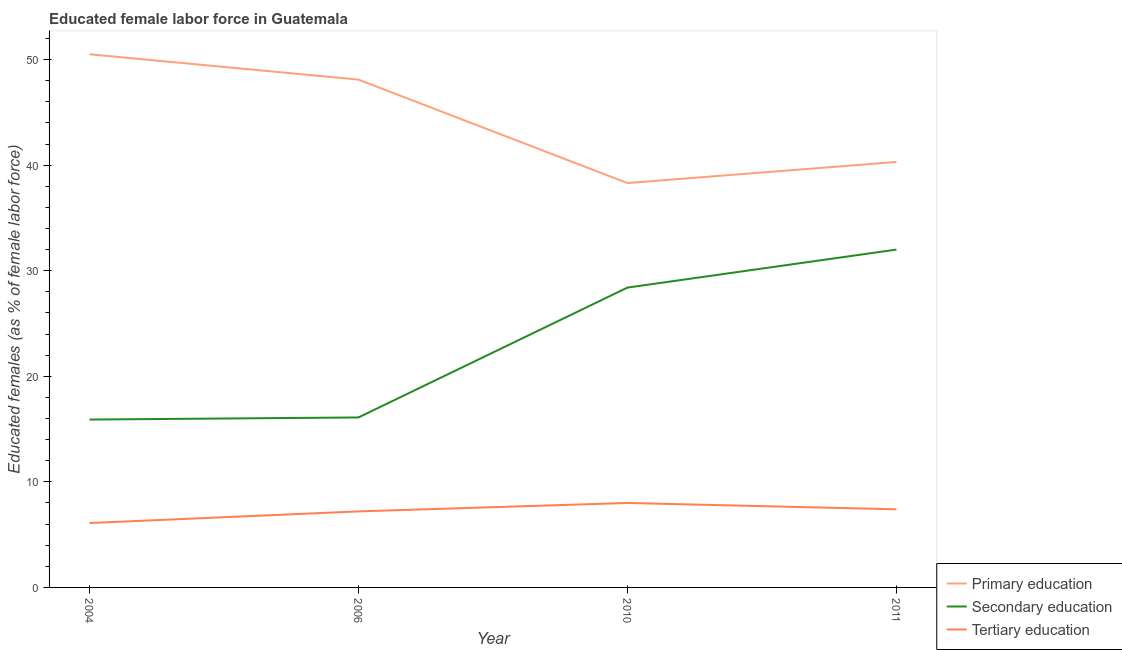How many different coloured lines are there?
Your answer should be very brief. 3. What is the percentage of female labor force who received primary education in 2006?
Offer a very short reply. 48.1. Across all years, what is the maximum percentage of female labor force who received primary education?
Your response must be concise. 50.5. Across all years, what is the minimum percentage of female labor force who received primary education?
Provide a short and direct response. 38.3. What is the total percentage of female labor force who received tertiary education in the graph?
Give a very brief answer. 28.7. What is the difference between the percentage of female labor force who received primary education in 2006 and that in 2011?
Your answer should be very brief. 7.8. What is the difference between the percentage of female labor force who received primary education in 2010 and the percentage of female labor force who received tertiary education in 2011?
Provide a short and direct response. 30.9. What is the average percentage of female labor force who received secondary education per year?
Your answer should be very brief. 23.1. In the year 2011, what is the difference between the percentage of female labor force who received tertiary education and percentage of female labor force who received secondary education?
Provide a short and direct response. -24.6. What is the ratio of the percentage of female labor force who received secondary education in 2004 to that in 2011?
Keep it short and to the point. 0.5. Is the difference between the percentage of female labor force who received primary education in 2004 and 2011 greater than the difference between the percentage of female labor force who received tertiary education in 2004 and 2011?
Your answer should be compact. Yes. What is the difference between the highest and the second highest percentage of female labor force who received secondary education?
Keep it short and to the point. 3.6. What is the difference between the highest and the lowest percentage of female labor force who received primary education?
Give a very brief answer. 12.2. In how many years, is the percentage of female labor force who received secondary education greater than the average percentage of female labor force who received secondary education taken over all years?
Your answer should be compact. 2. Is the percentage of female labor force who received tertiary education strictly less than the percentage of female labor force who received primary education over the years?
Ensure brevity in your answer.  Yes. How many lines are there?
Make the answer very short. 3. How many years are there in the graph?
Offer a terse response. 4. Does the graph contain grids?
Offer a very short reply. No. How many legend labels are there?
Provide a short and direct response. 3. How are the legend labels stacked?
Offer a terse response. Vertical. What is the title of the graph?
Your answer should be compact. Educated female labor force in Guatemala. What is the label or title of the Y-axis?
Keep it short and to the point. Educated females (as % of female labor force). What is the Educated females (as % of female labor force) of Primary education in 2004?
Ensure brevity in your answer.  50.5. What is the Educated females (as % of female labor force) in Secondary education in 2004?
Your response must be concise. 15.9. What is the Educated females (as % of female labor force) of Tertiary education in 2004?
Provide a succinct answer. 6.1. What is the Educated females (as % of female labor force) of Primary education in 2006?
Ensure brevity in your answer.  48.1. What is the Educated females (as % of female labor force) of Secondary education in 2006?
Give a very brief answer. 16.1. What is the Educated females (as % of female labor force) in Tertiary education in 2006?
Your answer should be compact. 7.2. What is the Educated females (as % of female labor force) in Primary education in 2010?
Keep it short and to the point. 38.3. What is the Educated females (as % of female labor force) in Secondary education in 2010?
Your answer should be very brief. 28.4. What is the Educated females (as % of female labor force) in Tertiary education in 2010?
Provide a succinct answer. 8. What is the Educated females (as % of female labor force) of Primary education in 2011?
Offer a very short reply. 40.3. What is the Educated females (as % of female labor force) in Tertiary education in 2011?
Offer a terse response. 7.4. Across all years, what is the maximum Educated females (as % of female labor force) in Primary education?
Make the answer very short. 50.5. Across all years, what is the maximum Educated females (as % of female labor force) in Secondary education?
Provide a succinct answer. 32. Across all years, what is the minimum Educated females (as % of female labor force) in Primary education?
Your response must be concise. 38.3. Across all years, what is the minimum Educated females (as % of female labor force) of Secondary education?
Give a very brief answer. 15.9. Across all years, what is the minimum Educated females (as % of female labor force) in Tertiary education?
Your answer should be compact. 6.1. What is the total Educated females (as % of female labor force) of Primary education in the graph?
Offer a very short reply. 177.2. What is the total Educated females (as % of female labor force) of Secondary education in the graph?
Your response must be concise. 92.4. What is the total Educated females (as % of female labor force) in Tertiary education in the graph?
Give a very brief answer. 28.7. What is the difference between the Educated females (as % of female labor force) in Tertiary education in 2004 and that in 2006?
Provide a short and direct response. -1.1. What is the difference between the Educated females (as % of female labor force) in Primary education in 2004 and that in 2010?
Provide a short and direct response. 12.2. What is the difference between the Educated females (as % of female labor force) of Secondary education in 2004 and that in 2010?
Make the answer very short. -12.5. What is the difference between the Educated females (as % of female labor force) in Secondary education in 2004 and that in 2011?
Offer a terse response. -16.1. What is the difference between the Educated females (as % of female labor force) of Tertiary education in 2004 and that in 2011?
Your answer should be very brief. -1.3. What is the difference between the Educated females (as % of female labor force) of Secondary education in 2006 and that in 2010?
Ensure brevity in your answer.  -12.3. What is the difference between the Educated females (as % of female labor force) in Secondary education in 2006 and that in 2011?
Keep it short and to the point. -15.9. What is the difference between the Educated females (as % of female labor force) in Primary education in 2010 and that in 2011?
Your response must be concise. -2. What is the difference between the Educated females (as % of female labor force) of Secondary education in 2010 and that in 2011?
Your answer should be compact. -3.6. What is the difference between the Educated females (as % of female labor force) of Primary education in 2004 and the Educated females (as % of female labor force) of Secondary education in 2006?
Give a very brief answer. 34.4. What is the difference between the Educated females (as % of female labor force) of Primary education in 2004 and the Educated females (as % of female labor force) of Tertiary education in 2006?
Your answer should be compact. 43.3. What is the difference between the Educated females (as % of female labor force) in Primary education in 2004 and the Educated females (as % of female labor force) in Secondary education in 2010?
Ensure brevity in your answer.  22.1. What is the difference between the Educated females (as % of female labor force) of Primary education in 2004 and the Educated females (as % of female labor force) of Tertiary education in 2010?
Keep it short and to the point. 42.5. What is the difference between the Educated females (as % of female labor force) of Primary education in 2004 and the Educated females (as % of female labor force) of Secondary education in 2011?
Offer a terse response. 18.5. What is the difference between the Educated females (as % of female labor force) of Primary education in 2004 and the Educated females (as % of female labor force) of Tertiary education in 2011?
Offer a very short reply. 43.1. What is the difference between the Educated females (as % of female labor force) of Secondary education in 2004 and the Educated females (as % of female labor force) of Tertiary education in 2011?
Your answer should be compact. 8.5. What is the difference between the Educated females (as % of female labor force) in Primary education in 2006 and the Educated females (as % of female labor force) in Tertiary education in 2010?
Offer a very short reply. 40.1. What is the difference between the Educated females (as % of female labor force) in Secondary education in 2006 and the Educated females (as % of female labor force) in Tertiary education in 2010?
Give a very brief answer. 8.1. What is the difference between the Educated females (as % of female labor force) of Primary education in 2006 and the Educated females (as % of female labor force) of Secondary education in 2011?
Provide a succinct answer. 16.1. What is the difference between the Educated females (as % of female labor force) of Primary education in 2006 and the Educated females (as % of female labor force) of Tertiary education in 2011?
Your answer should be very brief. 40.7. What is the difference between the Educated females (as % of female labor force) of Primary education in 2010 and the Educated females (as % of female labor force) of Tertiary education in 2011?
Your answer should be very brief. 30.9. What is the difference between the Educated females (as % of female labor force) in Secondary education in 2010 and the Educated females (as % of female labor force) in Tertiary education in 2011?
Your answer should be compact. 21. What is the average Educated females (as % of female labor force) in Primary education per year?
Your answer should be compact. 44.3. What is the average Educated females (as % of female labor force) in Secondary education per year?
Give a very brief answer. 23.1. What is the average Educated females (as % of female labor force) in Tertiary education per year?
Your answer should be very brief. 7.17. In the year 2004, what is the difference between the Educated females (as % of female labor force) of Primary education and Educated females (as % of female labor force) of Secondary education?
Your answer should be very brief. 34.6. In the year 2004, what is the difference between the Educated females (as % of female labor force) of Primary education and Educated females (as % of female labor force) of Tertiary education?
Your response must be concise. 44.4. In the year 2004, what is the difference between the Educated females (as % of female labor force) in Secondary education and Educated females (as % of female labor force) in Tertiary education?
Keep it short and to the point. 9.8. In the year 2006, what is the difference between the Educated females (as % of female labor force) in Primary education and Educated females (as % of female labor force) in Secondary education?
Your answer should be compact. 32. In the year 2006, what is the difference between the Educated females (as % of female labor force) of Primary education and Educated females (as % of female labor force) of Tertiary education?
Make the answer very short. 40.9. In the year 2010, what is the difference between the Educated females (as % of female labor force) of Primary education and Educated females (as % of female labor force) of Secondary education?
Offer a terse response. 9.9. In the year 2010, what is the difference between the Educated females (as % of female labor force) in Primary education and Educated females (as % of female labor force) in Tertiary education?
Ensure brevity in your answer.  30.3. In the year 2010, what is the difference between the Educated females (as % of female labor force) in Secondary education and Educated females (as % of female labor force) in Tertiary education?
Make the answer very short. 20.4. In the year 2011, what is the difference between the Educated females (as % of female labor force) of Primary education and Educated females (as % of female labor force) of Secondary education?
Give a very brief answer. 8.3. In the year 2011, what is the difference between the Educated females (as % of female labor force) of Primary education and Educated females (as % of female labor force) of Tertiary education?
Ensure brevity in your answer.  32.9. In the year 2011, what is the difference between the Educated females (as % of female labor force) in Secondary education and Educated females (as % of female labor force) in Tertiary education?
Provide a short and direct response. 24.6. What is the ratio of the Educated females (as % of female labor force) of Primary education in 2004 to that in 2006?
Give a very brief answer. 1.05. What is the ratio of the Educated females (as % of female labor force) of Secondary education in 2004 to that in 2006?
Offer a terse response. 0.99. What is the ratio of the Educated females (as % of female labor force) in Tertiary education in 2004 to that in 2006?
Your answer should be compact. 0.85. What is the ratio of the Educated females (as % of female labor force) in Primary education in 2004 to that in 2010?
Provide a succinct answer. 1.32. What is the ratio of the Educated females (as % of female labor force) in Secondary education in 2004 to that in 2010?
Offer a very short reply. 0.56. What is the ratio of the Educated females (as % of female labor force) in Tertiary education in 2004 to that in 2010?
Offer a very short reply. 0.76. What is the ratio of the Educated females (as % of female labor force) in Primary education in 2004 to that in 2011?
Provide a succinct answer. 1.25. What is the ratio of the Educated females (as % of female labor force) in Secondary education in 2004 to that in 2011?
Offer a very short reply. 0.5. What is the ratio of the Educated females (as % of female labor force) in Tertiary education in 2004 to that in 2011?
Your answer should be very brief. 0.82. What is the ratio of the Educated females (as % of female labor force) of Primary education in 2006 to that in 2010?
Offer a terse response. 1.26. What is the ratio of the Educated females (as % of female labor force) in Secondary education in 2006 to that in 2010?
Your response must be concise. 0.57. What is the ratio of the Educated females (as % of female labor force) of Tertiary education in 2006 to that in 2010?
Ensure brevity in your answer.  0.9. What is the ratio of the Educated females (as % of female labor force) of Primary education in 2006 to that in 2011?
Provide a succinct answer. 1.19. What is the ratio of the Educated females (as % of female labor force) of Secondary education in 2006 to that in 2011?
Keep it short and to the point. 0.5. What is the ratio of the Educated females (as % of female labor force) of Primary education in 2010 to that in 2011?
Give a very brief answer. 0.95. What is the ratio of the Educated females (as % of female labor force) in Secondary education in 2010 to that in 2011?
Offer a very short reply. 0.89. What is the ratio of the Educated females (as % of female labor force) in Tertiary education in 2010 to that in 2011?
Your response must be concise. 1.08. What is the difference between the highest and the second highest Educated females (as % of female labor force) in Primary education?
Your answer should be very brief. 2.4. What is the difference between the highest and the second highest Educated females (as % of female labor force) in Secondary education?
Your answer should be compact. 3.6. What is the difference between the highest and the second highest Educated females (as % of female labor force) in Tertiary education?
Ensure brevity in your answer.  0.6. What is the difference between the highest and the lowest Educated females (as % of female labor force) in Secondary education?
Your answer should be very brief. 16.1. What is the difference between the highest and the lowest Educated females (as % of female labor force) in Tertiary education?
Offer a terse response. 1.9. 